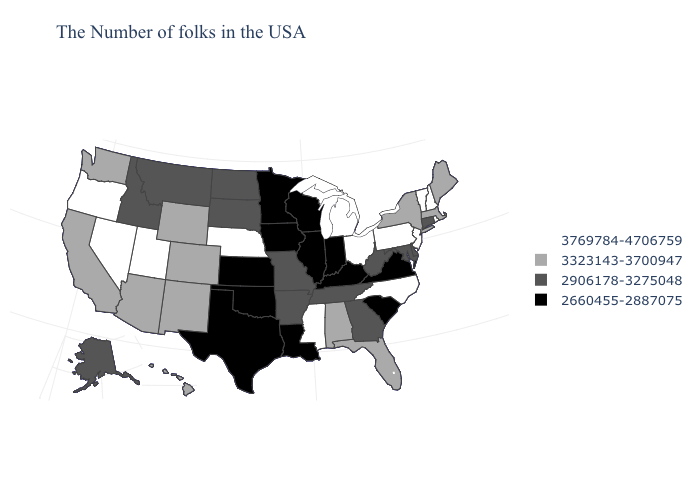Which states hav the highest value in the South?
Concise answer only. North Carolina, Mississippi. What is the value of Hawaii?
Keep it brief. 3323143-3700947. Name the states that have a value in the range 3323143-3700947?
Quick response, please. Maine, Massachusetts, New York, Florida, Alabama, Wyoming, Colorado, New Mexico, Arizona, California, Washington, Hawaii. Does Nebraska have the highest value in the USA?
Answer briefly. Yes. Which states hav the highest value in the MidWest?
Write a very short answer. Ohio, Michigan, Nebraska. Does Connecticut have the lowest value in the Northeast?
Answer briefly. Yes. What is the value of Mississippi?
Quick response, please. 3769784-4706759. How many symbols are there in the legend?
Give a very brief answer. 4. What is the value of Iowa?
Be succinct. 2660455-2887075. What is the lowest value in the Northeast?
Be succinct. 2906178-3275048. Name the states that have a value in the range 2906178-3275048?
Short answer required. Connecticut, Delaware, Maryland, West Virginia, Georgia, Tennessee, Missouri, Arkansas, South Dakota, North Dakota, Montana, Idaho, Alaska. What is the highest value in the MidWest ?
Quick response, please. 3769784-4706759. Does South Dakota have the lowest value in the MidWest?
Keep it brief. No. Name the states that have a value in the range 3323143-3700947?
Answer briefly. Maine, Massachusetts, New York, Florida, Alabama, Wyoming, Colorado, New Mexico, Arizona, California, Washington, Hawaii. 